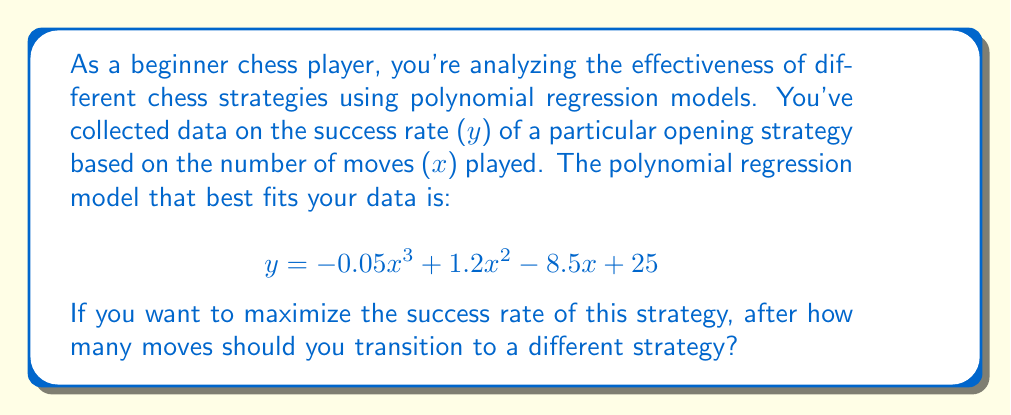Help me with this question. To find the number of moves that maximizes the success rate, we need to find the maximum point of the polynomial function. This can be done by following these steps:

1. Find the derivative of the function:
   $$ \frac{dy}{dx} = -0.15x^2 + 2.4x - 8.5 $$

2. Set the derivative equal to zero and solve for x:
   $$ -0.15x^2 + 2.4x - 8.5 = 0 $$

3. This is a quadratic equation. We can solve it using the quadratic formula:
   $$ x = \frac{-b \pm \sqrt{b^2 - 4ac}}{2a} $$
   where $a = -0.15$, $b = 2.4$, and $c = -8.5$

4. Plugging in the values:
   $$ x = \frac{-2.4 \pm \sqrt{2.4^2 - 4(-0.15)(-8.5)}}{2(-0.15)} $$
   $$ x = \frac{-2.4 \pm \sqrt{5.76 - 5.1}}{-0.3} $$
   $$ x = \frac{-2.4 \pm \sqrt{0.66}}{-0.3} $$
   $$ x = \frac{-2.4 \pm 0.8124}{-0.3} $$

5. This gives us two solutions:
   $$ x_1 = \frac{-2.4 + 0.8124}{-0.3} \approx 5.29 $$
   $$ x_2 = \frac{-2.4 - 0.8124}{-0.3} \approx 10.71 $$

6. To determine which solution gives the maximum, we can check the second derivative:
   $$ \frac{d^2y}{dx^2} = -0.3x + 2.4 $$

   At $x = 5.29$, the second derivative is negative, indicating a maximum.
   At $x = 10.71$, the second derivative is positive, indicating a minimum.

Therefore, the success rate is maximized at approximately 5.29 moves. Since we're dealing with chess moves, we need to round to the nearest whole number.
Answer: The success rate of the strategy is maximized after 5 moves. 